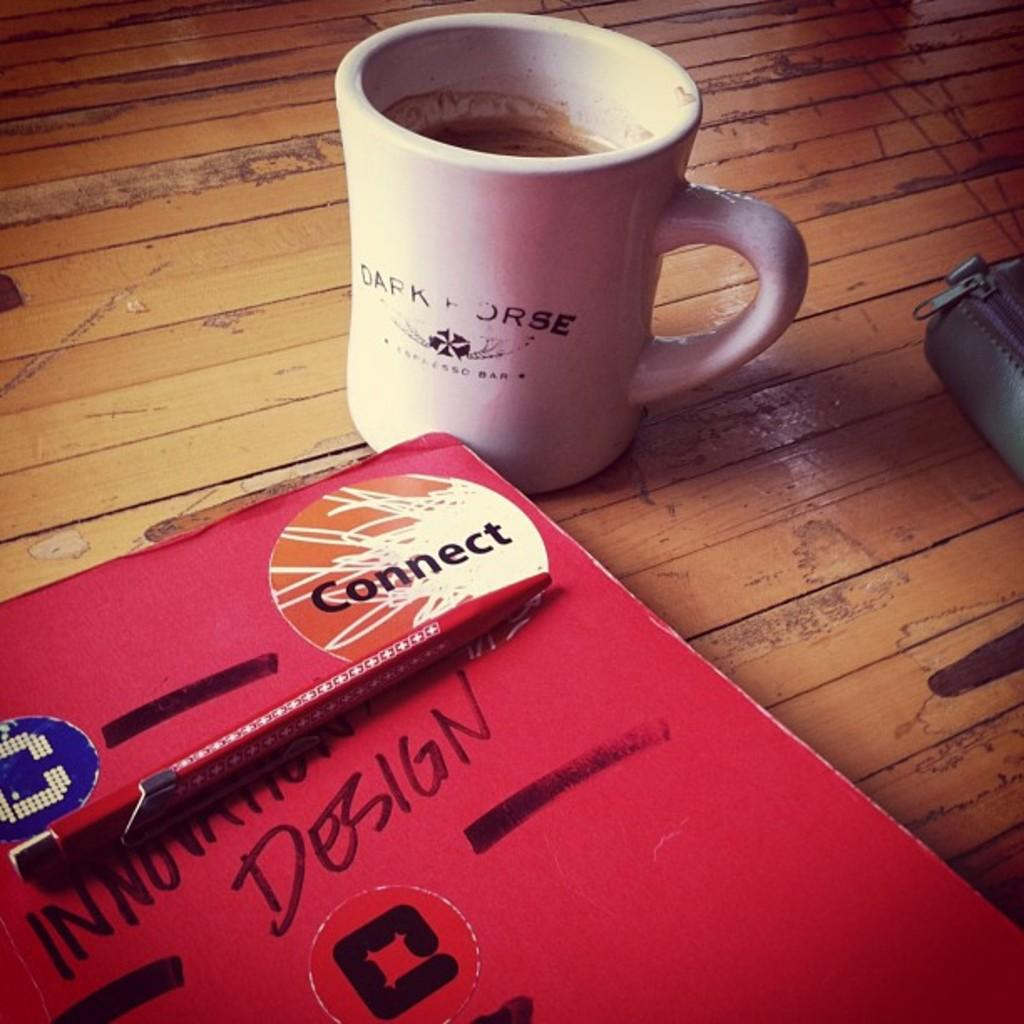<image>
Relay a brief, clear account of the picture shown. A red notebook with the word Design on it with a coffee mug next to it sitting on a table. 